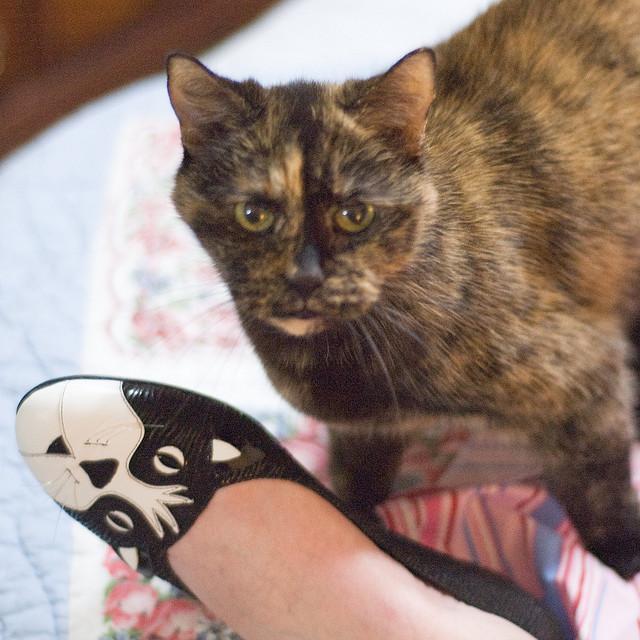What is one of the largest breeds of this animal?
Indicate the correct response by choosing from the four available options to answer the question.
Options: Maine coon, greyhound, munchkin, doberman. Maine coon. 